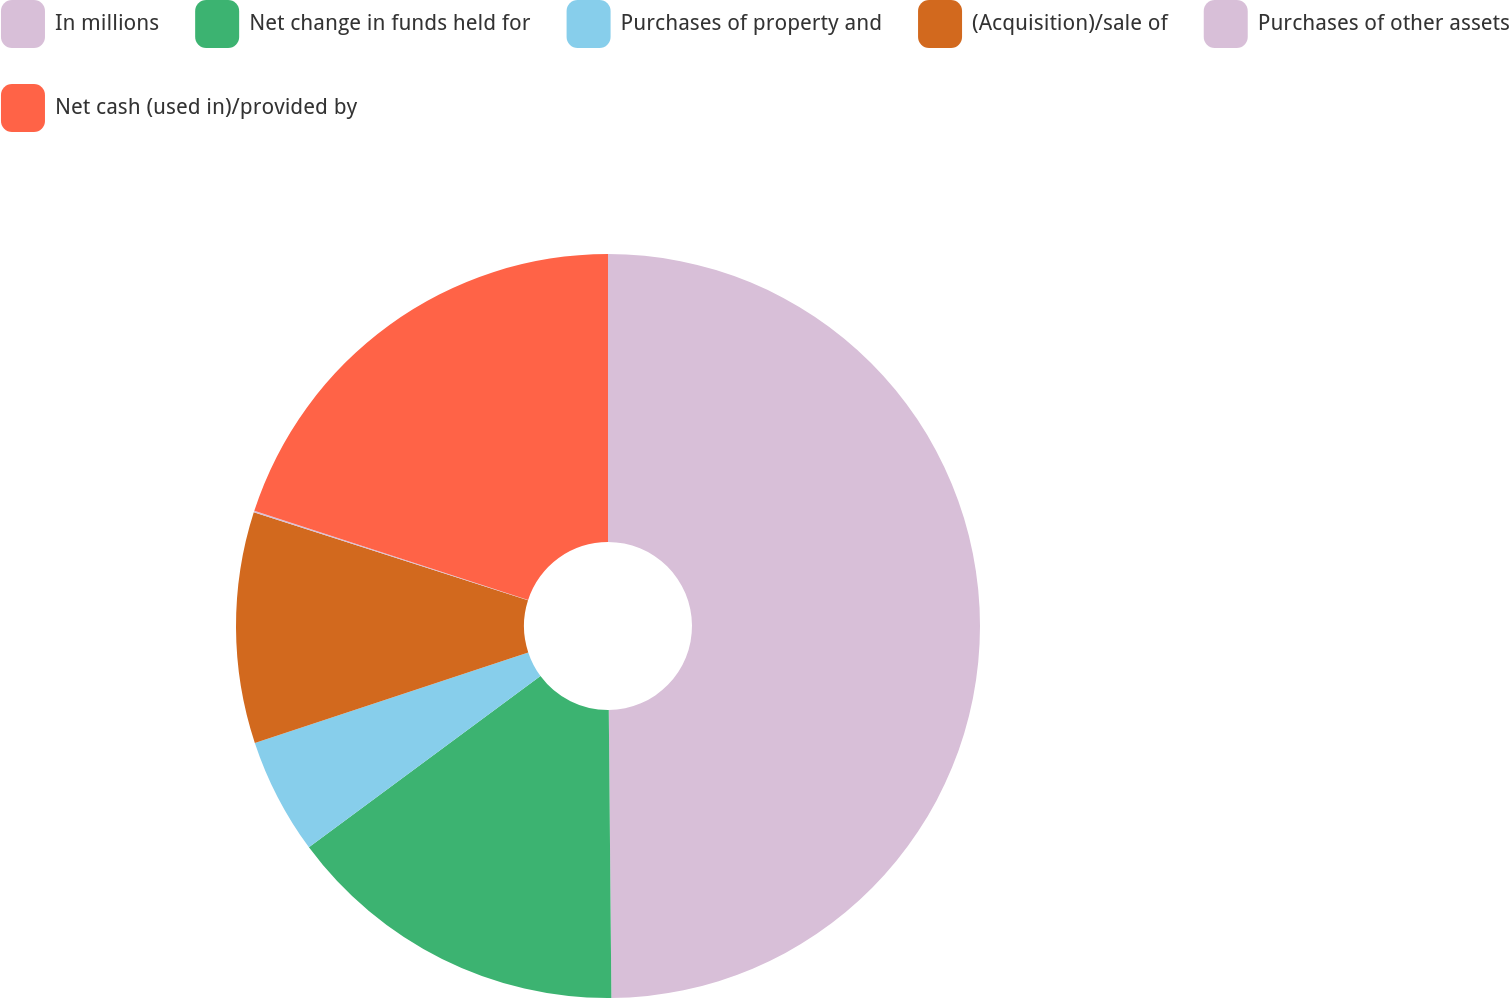<chart> <loc_0><loc_0><loc_500><loc_500><pie_chart><fcel>In millions<fcel>Net change in funds held for<fcel>Purchases of property and<fcel>(Acquisition)/sale of<fcel>Purchases of other assets<fcel>Net cash (used in)/provided by<nl><fcel>49.86%<fcel>15.01%<fcel>5.05%<fcel>10.03%<fcel>0.07%<fcel>19.99%<nl></chart> 